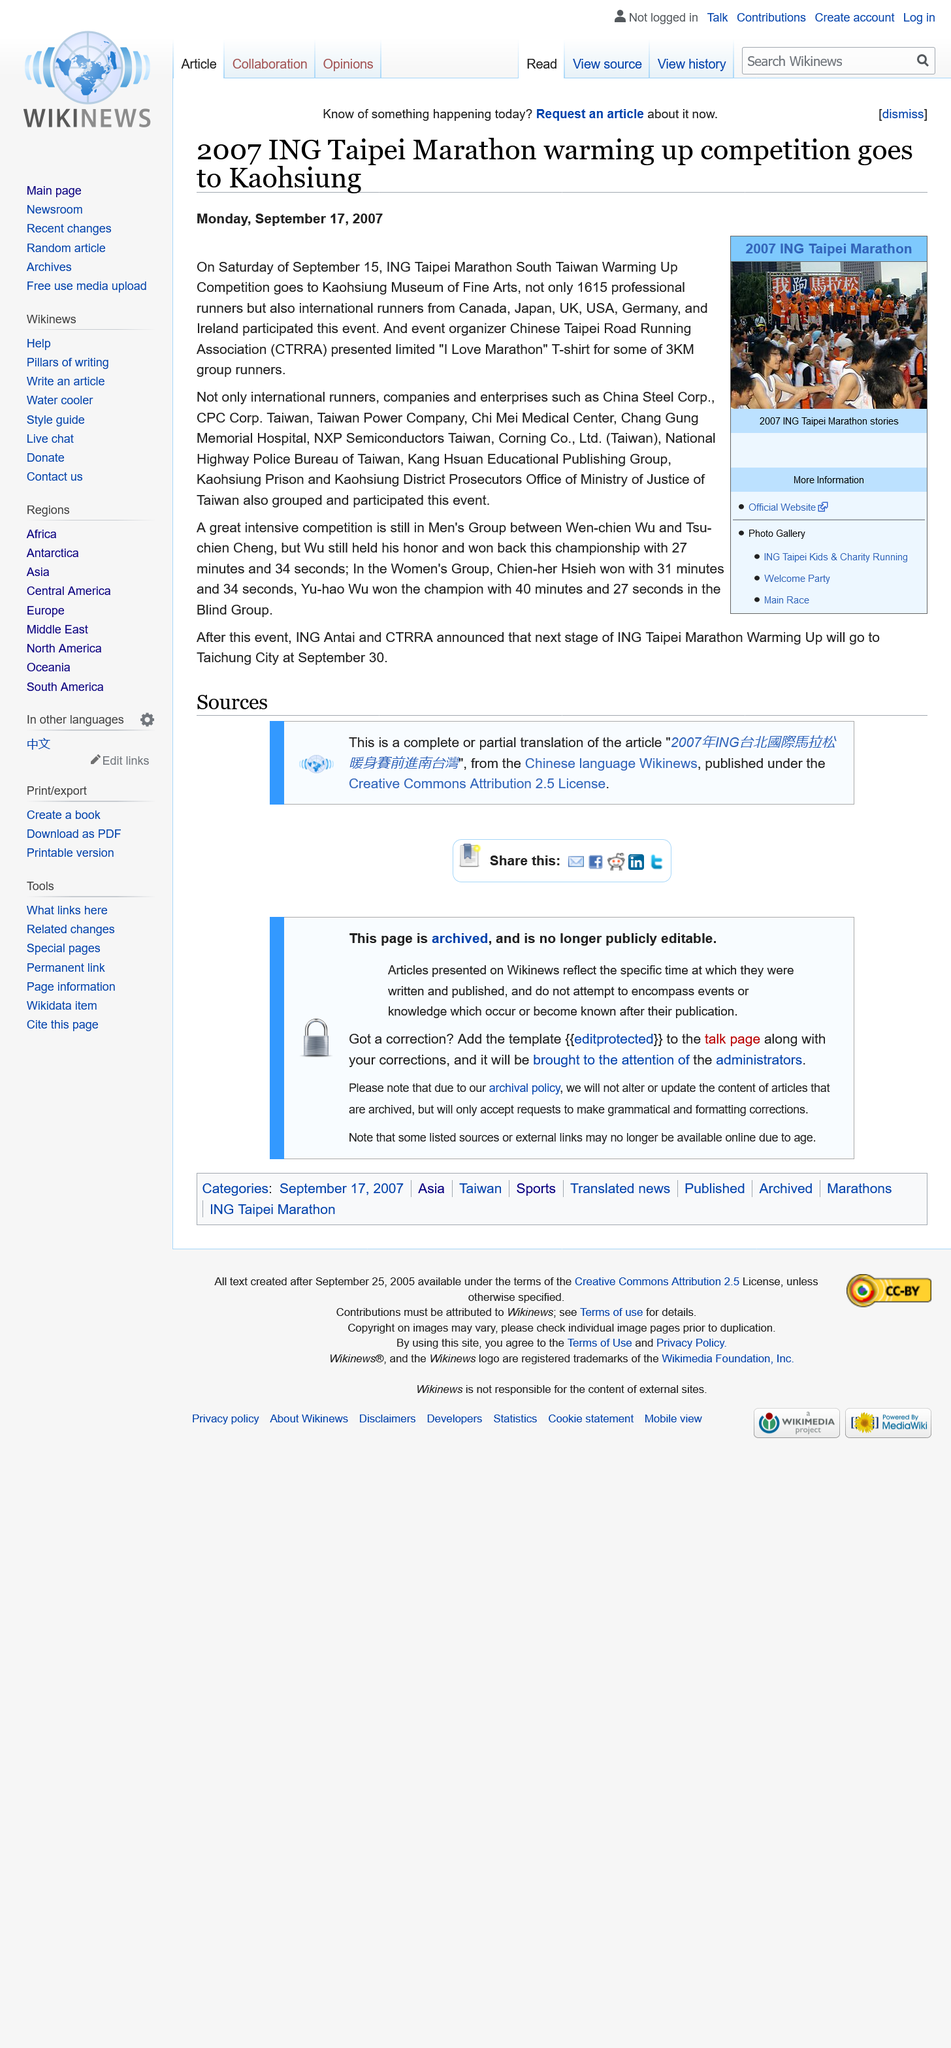Specify some key components in this picture. The 2007 ING Taipei Marathon warming up competition took place on a Saturday. The article about the 2007 ING Taipei Marathon warming up competition was published on Monday, September 17, 2007. The ING Taipei Marathon warming up competition in 2007 took place in Kaohsiung. 